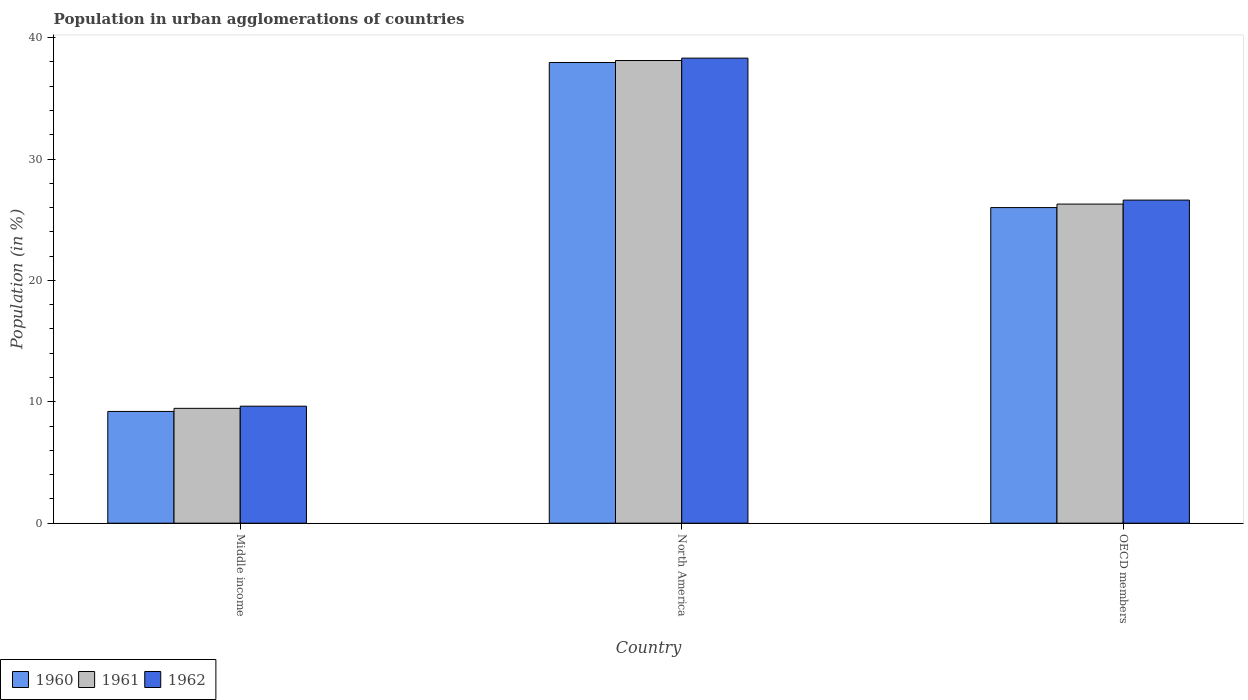How many different coloured bars are there?
Offer a terse response. 3. Are the number of bars per tick equal to the number of legend labels?
Provide a succinct answer. Yes. Are the number of bars on each tick of the X-axis equal?
Your answer should be compact. Yes. How many bars are there on the 2nd tick from the right?
Your answer should be very brief. 3. What is the label of the 1st group of bars from the left?
Give a very brief answer. Middle income. What is the percentage of population in urban agglomerations in 1962 in North America?
Offer a very short reply. 38.31. Across all countries, what is the maximum percentage of population in urban agglomerations in 1960?
Keep it short and to the point. 37.95. Across all countries, what is the minimum percentage of population in urban agglomerations in 1962?
Ensure brevity in your answer.  9.64. What is the total percentage of population in urban agglomerations in 1960 in the graph?
Ensure brevity in your answer.  73.16. What is the difference between the percentage of population in urban agglomerations in 1961 in Middle income and that in OECD members?
Provide a succinct answer. -16.83. What is the difference between the percentage of population in urban agglomerations in 1961 in North America and the percentage of population in urban agglomerations in 1962 in OECD members?
Keep it short and to the point. 11.5. What is the average percentage of population in urban agglomerations in 1961 per country?
Give a very brief answer. 24.62. What is the difference between the percentage of population in urban agglomerations of/in 1961 and percentage of population in urban agglomerations of/in 1960 in Middle income?
Give a very brief answer. 0.26. What is the ratio of the percentage of population in urban agglomerations in 1960 in North America to that in OECD members?
Keep it short and to the point. 1.46. Is the difference between the percentage of population in urban agglomerations in 1961 in Middle income and North America greater than the difference between the percentage of population in urban agglomerations in 1960 in Middle income and North America?
Keep it short and to the point. Yes. What is the difference between the highest and the second highest percentage of population in urban agglomerations in 1961?
Ensure brevity in your answer.  -16.83. What is the difference between the highest and the lowest percentage of population in urban agglomerations in 1961?
Make the answer very short. 28.65. In how many countries, is the percentage of population in urban agglomerations in 1962 greater than the average percentage of population in urban agglomerations in 1962 taken over all countries?
Offer a very short reply. 2. Is the sum of the percentage of population in urban agglomerations in 1961 in North America and OECD members greater than the maximum percentage of population in urban agglomerations in 1962 across all countries?
Your answer should be very brief. Yes. Is it the case that in every country, the sum of the percentage of population in urban agglomerations in 1962 and percentage of population in urban agglomerations in 1960 is greater than the percentage of population in urban agglomerations in 1961?
Offer a terse response. Yes. How many bars are there?
Keep it short and to the point. 9. How many countries are there in the graph?
Your answer should be very brief. 3. What is the difference between two consecutive major ticks on the Y-axis?
Keep it short and to the point. 10. Are the values on the major ticks of Y-axis written in scientific E-notation?
Ensure brevity in your answer.  No. Does the graph contain grids?
Offer a very short reply. No. How are the legend labels stacked?
Ensure brevity in your answer.  Horizontal. What is the title of the graph?
Provide a succinct answer. Population in urban agglomerations of countries. Does "1995" appear as one of the legend labels in the graph?
Your response must be concise. No. What is the label or title of the X-axis?
Your response must be concise. Country. What is the Population (in %) of 1960 in Middle income?
Keep it short and to the point. 9.21. What is the Population (in %) in 1961 in Middle income?
Offer a very short reply. 9.46. What is the Population (in %) of 1962 in Middle income?
Provide a succinct answer. 9.64. What is the Population (in %) in 1960 in North America?
Keep it short and to the point. 37.95. What is the Population (in %) of 1961 in North America?
Provide a short and direct response. 38.12. What is the Population (in %) of 1962 in North America?
Provide a succinct answer. 38.31. What is the Population (in %) in 1960 in OECD members?
Ensure brevity in your answer.  26. What is the Population (in %) in 1961 in OECD members?
Provide a short and direct response. 26.29. What is the Population (in %) in 1962 in OECD members?
Keep it short and to the point. 26.62. Across all countries, what is the maximum Population (in %) of 1960?
Your answer should be very brief. 37.95. Across all countries, what is the maximum Population (in %) in 1961?
Make the answer very short. 38.12. Across all countries, what is the maximum Population (in %) in 1962?
Give a very brief answer. 38.31. Across all countries, what is the minimum Population (in %) of 1960?
Offer a terse response. 9.21. Across all countries, what is the minimum Population (in %) in 1961?
Your response must be concise. 9.46. Across all countries, what is the minimum Population (in %) in 1962?
Make the answer very short. 9.64. What is the total Population (in %) in 1960 in the graph?
Offer a very short reply. 73.16. What is the total Population (in %) of 1961 in the graph?
Make the answer very short. 73.87. What is the total Population (in %) in 1962 in the graph?
Give a very brief answer. 74.57. What is the difference between the Population (in %) of 1960 in Middle income and that in North America?
Keep it short and to the point. -28.75. What is the difference between the Population (in %) in 1961 in Middle income and that in North America?
Your answer should be very brief. -28.65. What is the difference between the Population (in %) of 1962 in Middle income and that in North America?
Provide a succinct answer. -28.68. What is the difference between the Population (in %) of 1960 in Middle income and that in OECD members?
Offer a very short reply. -16.79. What is the difference between the Population (in %) in 1961 in Middle income and that in OECD members?
Make the answer very short. -16.83. What is the difference between the Population (in %) of 1962 in Middle income and that in OECD members?
Ensure brevity in your answer.  -16.98. What is the difference between the Population (in %) of 1960 in North America and that in OECD members?
Make the answer very short. 11.95. What is the difference between the Population (in %) of 1961 in North America and that in OECD members?
Your response must be concise. 11.83. What is the difference between the Population (in %) in 1962 in North America and that in OECD members?
Give a very brief answer. 11.7. What is the difference between the Population (in %) in 1960 in Middle income and the Population (in %) in 1961 in North America?
Make the answer very short. -28.91. What is the difference between the Population (in %) of 1960 in Middle income and the Population (in %) of 1962 in North America?
Your answer should be very brief. -29.11. What is the difference between the Population (in %) of 1961 in Middle income and the Population (in %) of 1962 in North America?
Your answer should be compact. -28.85. What is the difference between the Population (in %) of 1960 in Middle income and the Population (in %) of 1961 in OECD members?
Keep it short and to the point. -17.08. What is the difference between the Population (in %) in 1960 in Middle income and the Population (in %) in 1962 in OECD members?
Give a very brief answer. -17.41. What is the difference between the Population (in %) in 1961 in Middle income and the Population (in %) in 1962 in OECD members?
Your response must be concise. -17.15. What is the difference between the Population (in %) of 1960 in North America and the Population (in %) of 1961 in OECD members?
Make the answer very short. 11.66. What is the difference between the Population (in %) of 1960 in North America and the Population (in %) of 1962 in OECD members?
Ensure brevity in your answer.  11.34. What is the difference between the Population (in %) of 1961 in North America and the Population (in %) of 1962 in OECD members?
Your answer should be compact. 11.5. What is the average Population (in %) in 1960 per country?
Keep it short and to the point. 24.39. What is the average Population (in %) of 1961 per country?
Provide a succinct answer. 24.62. What is the average Population (in %) in 1962 per country?
Your answer should be compact. 24.86. What is the difference between the Population (in %) in 1960 and Population (in %) in 1961 in Middle income?
Your response must be concise. -0.26. What is the difference between the Population (in %) of 1960 and Population (in %) of 1962 in Middle income?
Give a very brief answer. -0.43. What is the difference between the Population (in %) in 1961 and Population (in %) in 1962 in Middle income?
Keep it short and to the point. -0.18. What is the difference between the Population (in %) in 1960 and Population (in %) in 1961 in North America?
Your answer should be compact. -0.16. What is the difference between the Population (in %) of 1960 and Population (in %) of 1962 in North America?
Provide a succinct answer. -0.36. What is the difference between the Population (in %) in 1961 and Population (in %) in 1962 in North America?
Ensure brevity in your answer.  -0.2. What is the difference between the Population (in %) of 1960 and Population (in %) of 1961 in OECD members?
Ensure brevity in your answer.  -0.29. What is the difference between the Population (in %) in 1960 and Population (in %) in 1962 in OECD members?
Offer a terse response. -0.62. What is the difference between the Population (in %) of 1961 and Population (in %) of 1962 in OECD members?
Offer a very short reply. -0.33. What is the ratio of the Population (in %) in 1960 in Middle income to that in North America?
Your response must be concise. 0.24. What is the ratio of the Population (in %) of 1961 in Middle income to that in North America?
Offer a very short reply. 0.25. What is the ratio of the Population (in %) of 1962 in Middle income to that in North America?
Keep it short and to the point. 0.25. What is the ratio of the Population (in %) in 1960 in Middle income to that in OECD members?
Give a very brief answer. 0.35. What is the ratio of the Population (in %) in 1961 in Middle income to that in OECD members?
Offer a terse response. 0.36. What is the ratio of the Population (in %) in 1962 in Middle income to that in OECD members?
Your response must be concise. 0.36. What is the ratio of the Population (in %) in 1960 in North America to that in OECD members?
Your response must be concise. 1.46. What is the ratio of the Population (in %) of 1961 in North America to that in OECD members?
Provide a succinct answer. 1.45. What is the ratio of the Population (in %) of 1962 in North America to that in OECD members?
Ensure brevity in your answer.  1.44. What is the difference between the highest and the second highest Population (in %) in 1960?
Give a very brief answer. 11.95. What is the difference between the highest and the second highest Population (in %) of 1961?
Ensure brevity in your answer.  11.83. What is the difference between the highest and the second highest Population (in %) of 1962?
Your response must be concise. 11.7. What is the difference between the highest and the lowest Population (in %) of 1960?
Your response must be concise. 28.75. What is the difference between the highest and the lowest Population (in %) of 1961?
Offer a very short reply. 28.65. What is the difference between the highest and the lowest Population (in %) in 1962?
Your answer should be compact. 28.68. 